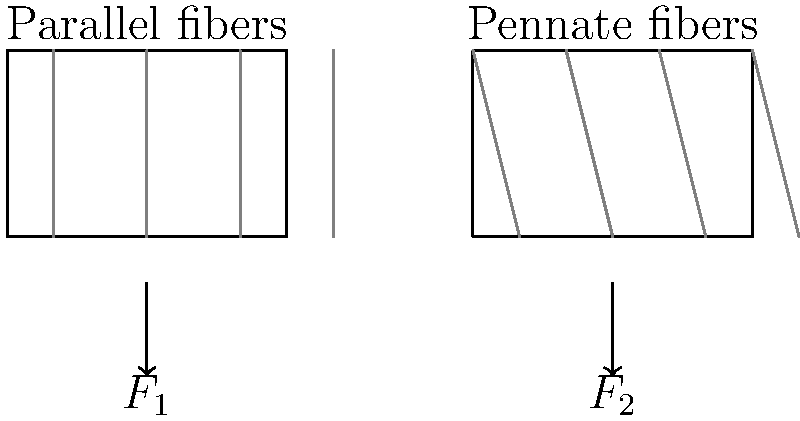Consider the two simplified muscle diagrams above, representing muscles with parallel fibers and pennate fibers. Assuming both muscles have the same physiological cross-sectional area (PCSA) and are maximally activated, which muscle would produce greater force along its longitudinal axis? Explain your reasoning, considering the legal and ethical implications of using such biomechanical data in database management for health-related applications. To answer this question, we need to consider the following steps:

1. Muscle force production:
   The force a muscle can produce is primarily determined by its physiological cross-sectional area (PCSA). Since both muscles have the same PCSA, they have the same potential for force production.

2. Fiber orientation:
   - Parallel fibers: All fibers are oriented along the muscle's longitudinal axis.
   - Pennate fibers: Fibers are oriented at an angle to the muscle's longitudinal axis.

3. Force vector analysis:
   - Parallel fibers: The entire force generated by each fiber contributes to the longitudinal force (F1).
   - Pennate fibers: Only a component of the force generated by each fiber contributes to the longitudinal force (F2).

4. Cosine effect:
   For pennate fibers, the longitudinal force component is calculated using the cosine of the pennation angle:
   $$F_{\text{longitudinal}} = F_{\text{fiber}} \cdot \cos(\theta)$$
   where $\theta$ is the pennation angle.

5. Result:
   The muscle with parallel fibers (F1) will produce greater force along its longitudinal axis compared to the muscle with pennate fibers (F2), assuming equal PCSA and maximal activation.

Legal and ethical considerations:
1. Data privacy: Storing and managing biomechanical data requires adherence to data protection regulations (e.g., GDPR, HIPAA) to ensure individual privacy.
2. Informed consent: Subjects providing biomechanical data must be fully informed about data usage and storage practices.
3. Data accuracy: Ensuring the accuracy of biomechanical data is crucial for making informed decisions in health-related applications.
4. Ethical use: The data should be used responsibly, avoiding discrimination or unfair treatment based on biomechanical characteristics.
5. Data security: Implementing robust security measures to protect sensitive biomechanical information from unauthorized access or breaches.

These considerations are essential when managing databases containing biomechanical information to maintain legal compliance and ethical standards in health-related applications.
Answer: Parallel fiber muscle produces greater longitudinal force; legal and ethical considerations include data privacy, informed consent, accuracy, responsible use, and security in database management. 